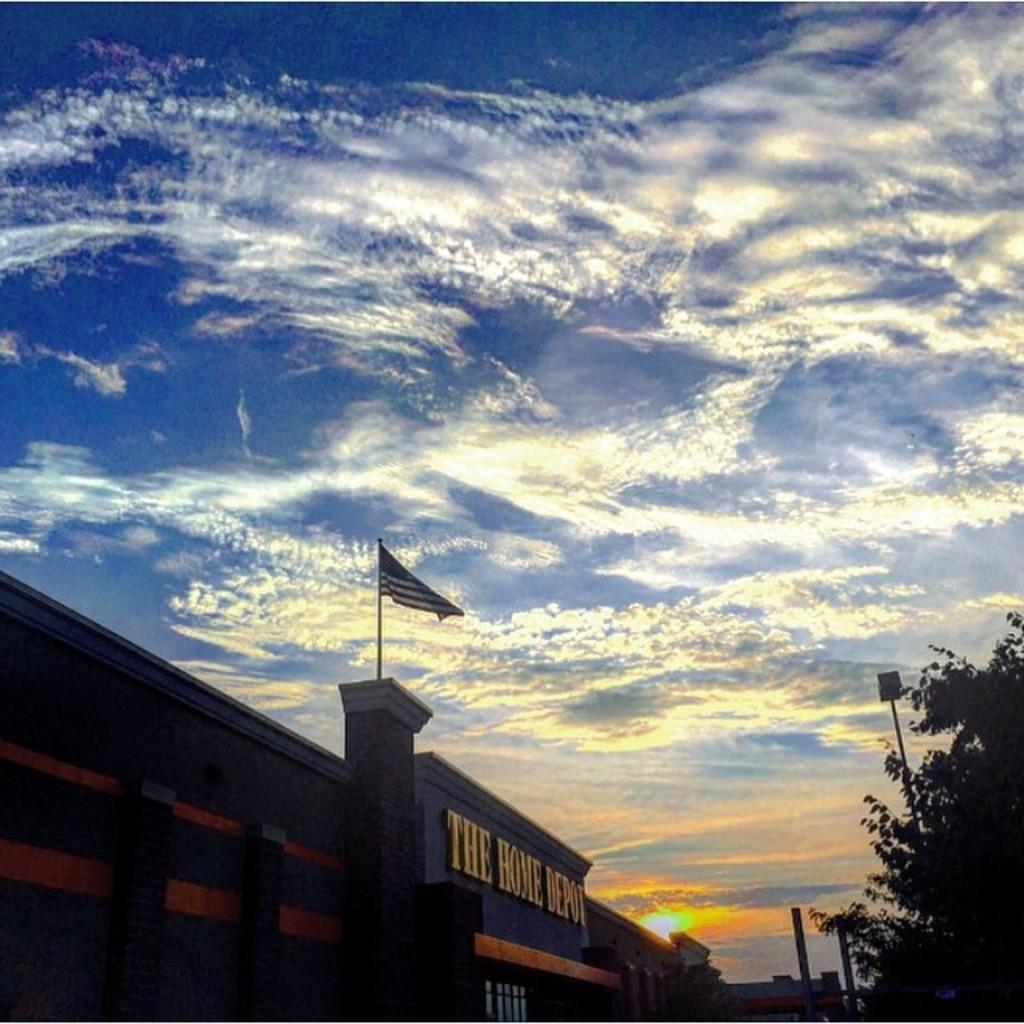What structure is located at the bottom of the image? There is a building at the bottom of the image. What is attached to the building? A flag is present on the building. What type of vegetation is on the right side of the image? There are trees on the right side of the image. What is visible at the top of the image? The sky is visible at the top of the image. What type of cloth is draped over the ornament in the image? There is no cloth or ornament present in the image. Can you describe the tub in the image? There is no tub present in the image. 